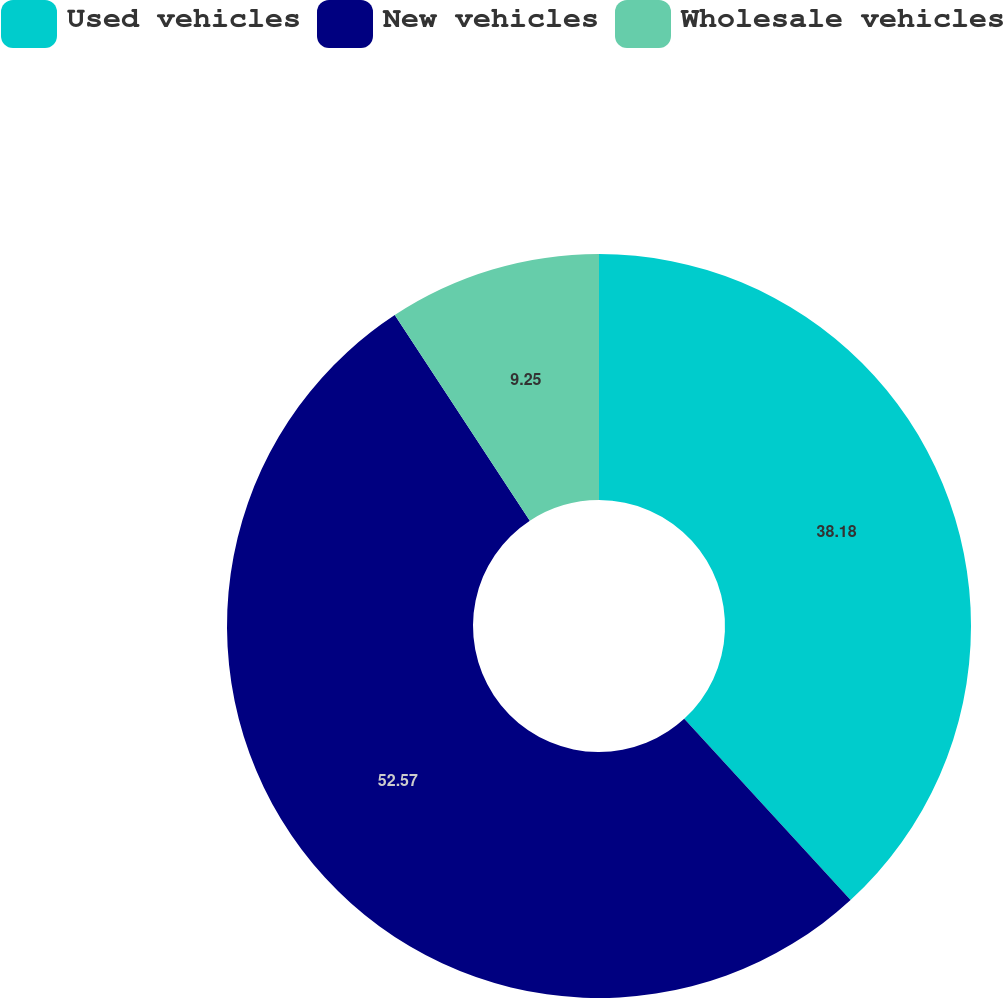<chart> <loc_0><loc_0><loc_500><loc_500><pie_chart><fcel>Used vehicles<fcel>New vehicles<fcel>Wholesale vehicles<nl><fcel>38.18%<fcel>52.57%<fcel>9.25%<nl></chart> 